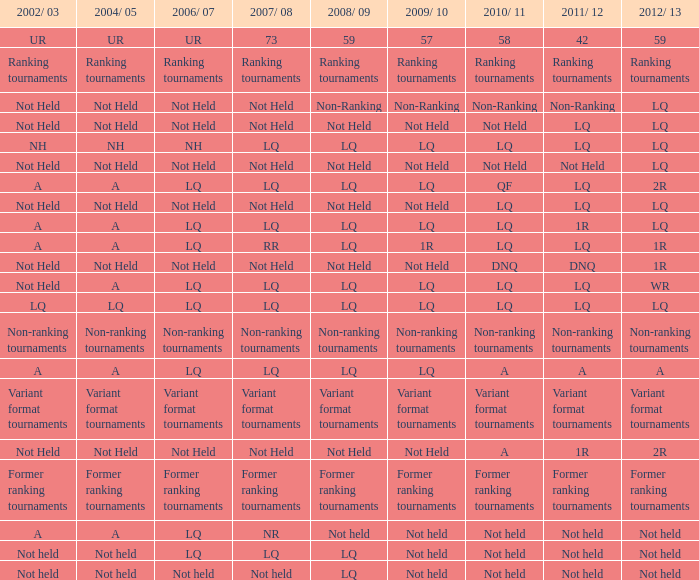Name the 2011/12 with 2008/09 of not held with 2010/11 of not held LQ, Not Held, Not held. 